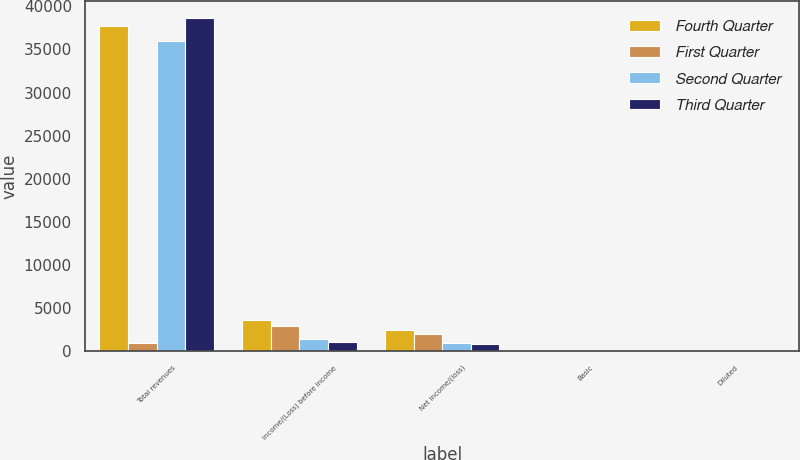Convert chart to OTSL. <chart><loc_0><loc_0><loc_500><loc_500><stacked_bar_chart><ecel><fcel>Total revenues<fcel>Income/(Loss) before income<fcel>Net income/(loss)<fcel>Basic<fcel>Diluted<nl><fcel>Fourth Quarter<fcel>37718<fcel>3651<fcel>2452<fcel>0.62<fcel>0.61<nl><fcel>First Quarter<fcel>957<fcel>2875<fcel>1970<fcel>0.5<fcel>0.49<nl><fcel>Second Quarter<fcel>35943<fcel>1387<fcel>957<fcel>0.24<fcel>0.24<nl><fcel>Third Quarter<fcel>38654<fcel>1117<fcel>783<fcel>0.2<fcel>0.2<nl></chart> 